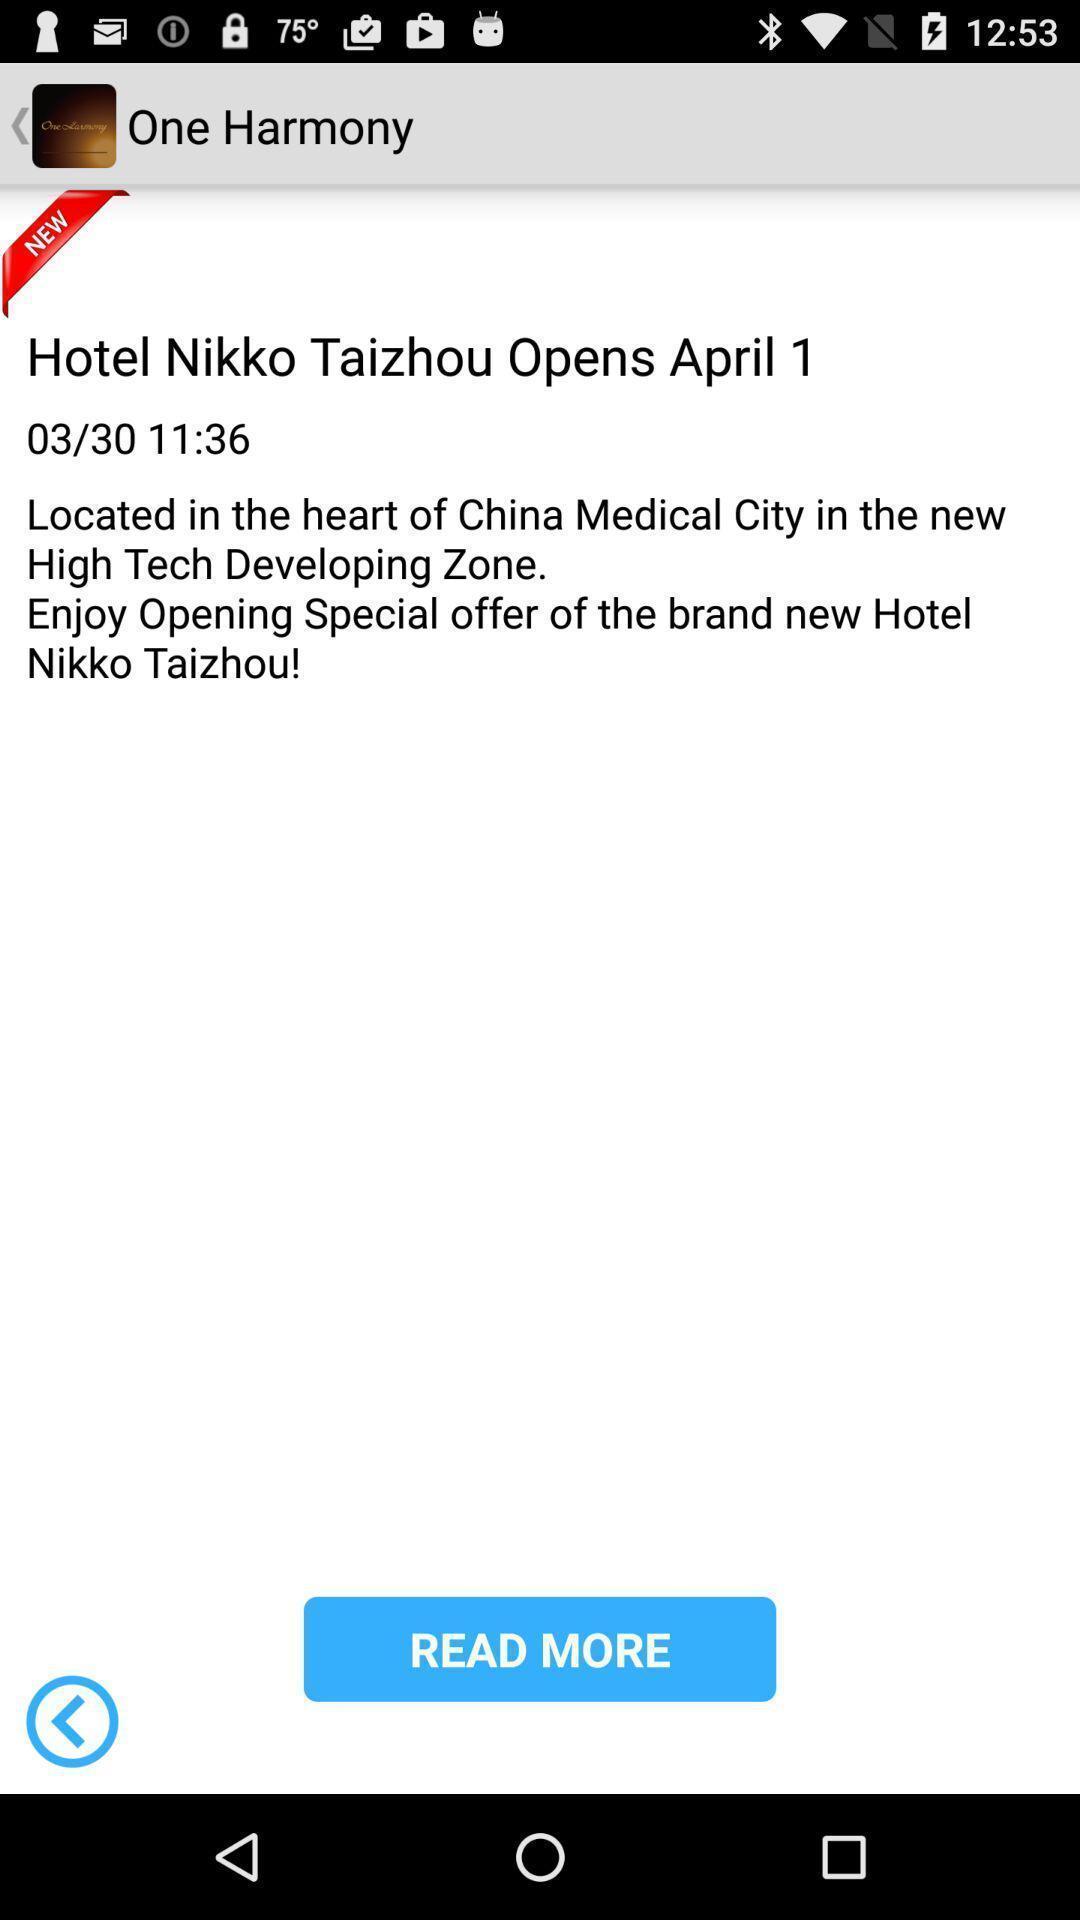Give me a summary of this screen capture. Screen showing about the hotel. 